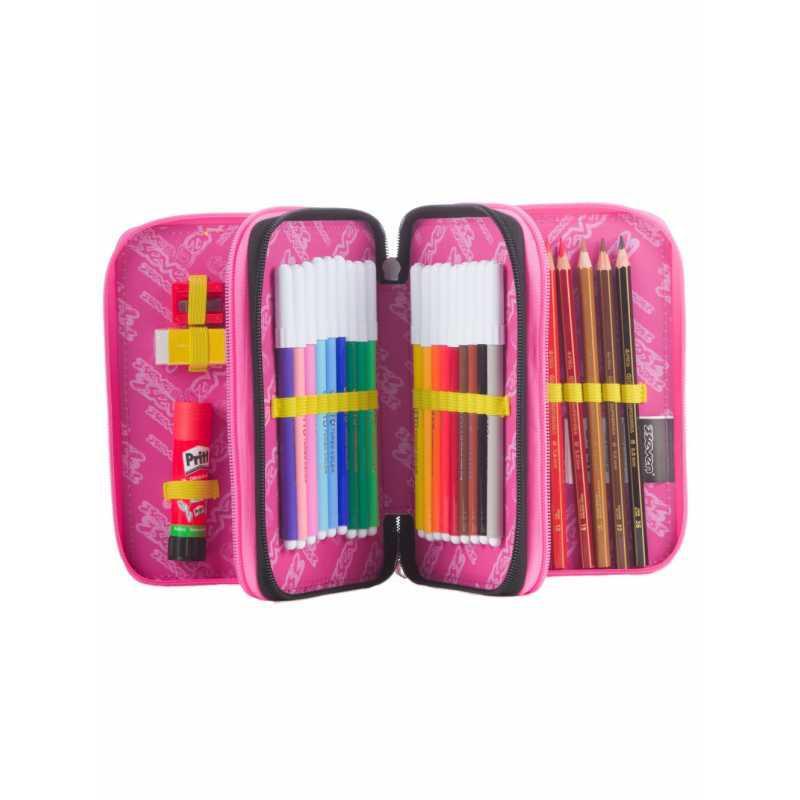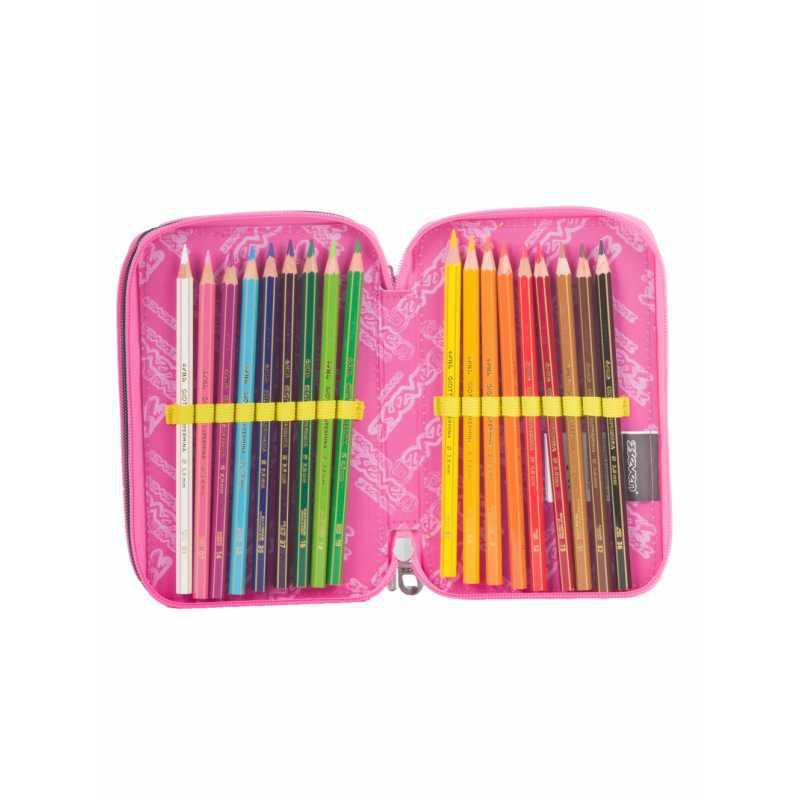The first image is the image on the left, the second image is the image on the right. Assess this claim about the two images: "At least one pencil case has a pink inner lining.". Correct or not? Answer yes or no. Yes. The first image is the image on the left, the second image is the image on the right. Evaluate the accuracy of this statement regarding the images: "One image shows a pencil case with a pink interior displayed so its multiple inner compartments fan out.". Is it true? Answer yes or no. Yes. 